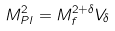Convert formula to latex. <formula><loc_0><loc_0><loc_500><loc_500>M _ { P l } ^ { 2 } = M _ { f } ^ { 2 + \delta } V _ { \delta }</formula> 